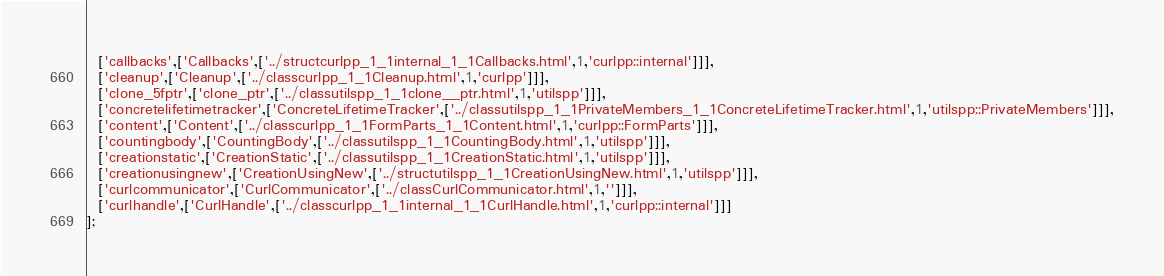<code> <loc_0><loc_0><loc_500><loc_500><_JavaScript_>  ['callbacks',['Callbacks',['../structcurlpp_1_1internal_1_1Callbacks.html',1,'curlpp::internal']]],
  ['cleanup',['Cleanup',['../classcurlpp_1_1Cleanup.html',1,'curlpp']]],
  ['clone_5fptr',['clone_ptr',['../classutilspp_1_1clone__ptr.html',1,'utilspp']]],
  ['concretelifetimetracker',['ConcreteLifetimeTracker',['../classutilspp_1_1PrivateMembers_1_1ConcreteLifetimeTracker.html',1,'utilspp::PrivateMembers']]],
  ['content',['Content',['../classcurlpp_1_1FormParts_1_1Content.html',1,'curlpp::FormParts']]],
  ['countingbody',['CountingBody',['../classutilspp_1_1CountingBody.html',1,'utilspp']]],
  ['creationstatic',['CreationStatic',['../classutilspp_1_1CreationStatic.html',1,'utilspp']]],
  ['creationusingnew',['CreationUsingNew',['../structutilspp_1_1CreationUsingNew.html',1,'utilspp']]],
  ['curlcommunicator',['CurlCommunicator',['../classCurlCommunicator.html',1,'']]],
  ['curlhandle',['CurlHandle',['../classcurlpp_1_1internal_1_1CurlHandle.html',1,'curlpp::internal']]]
];
</code> 